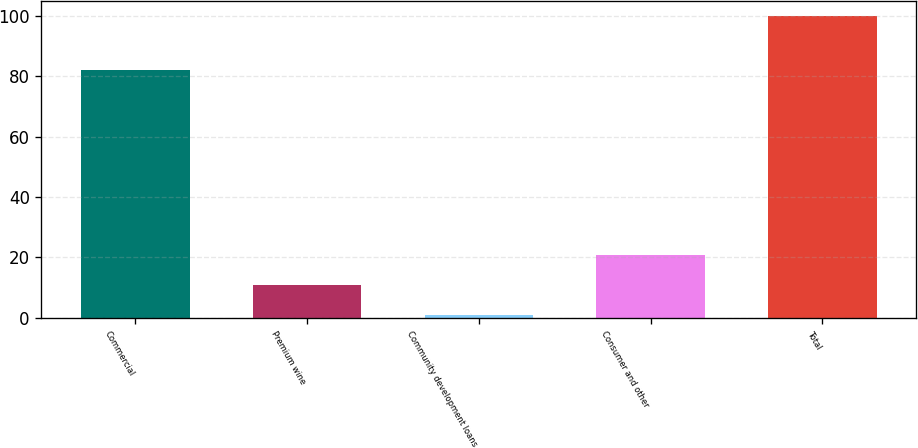<chart> <loc_0><loc_0><loc_500><loc_500><bar_chart><fcel>Commercial<fcel>Premium wine<fcel>Community development loans<fcel>Consumer and other<fcel>Total<nl><fcel>82<fcel>10.81<fcel>0.9<fcel>20.72<fcel>100<nl></chart> 